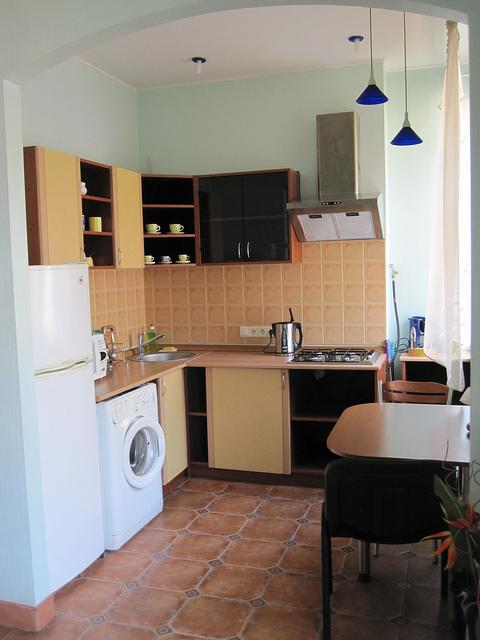What is the small white appliance? Please explain your reasoning. clothes washer. This has a round circle door on the front for clothes 